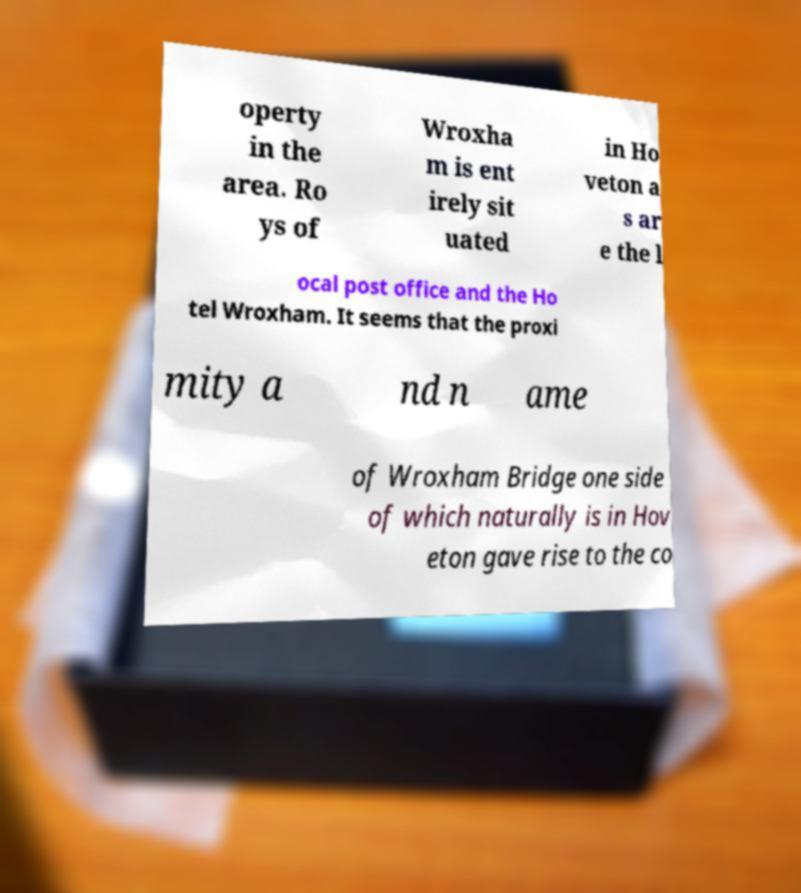What messages or text are displayed in this image? I need them in a readable, typed format. operty in the area. Ro ys of Wroxha m is ent irely sit uated in Ho veton a s ar e the l ocal post office and the Ho tel Wroxham. It seems that the proxi mity a nd n ame of Wroxham Bridge one side of which naturally is in Hov eton gave rise to the co 